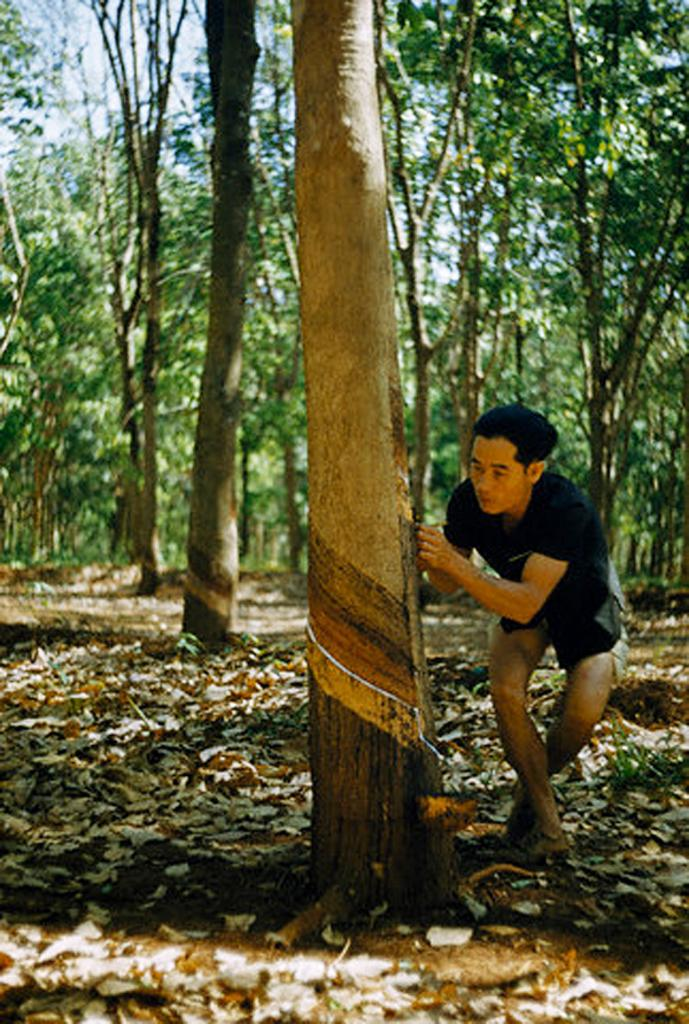What is the man in the image doing? The man is standing in the image. What is the man holding in the image? The man is holding an object in the image. What can be seen in the background of the image? Trees and the sky are visible in the background of the image. What is visible at the bottom of the image? The ground is visible at the bottom of the image. What is present on the ground in the image? Dried leaves are present on the ground in the image. How many ants can be seen crawling on the man's brother in the image? There is no mention of ants or the man's brother in the image, so it is not possible to answer this question. 